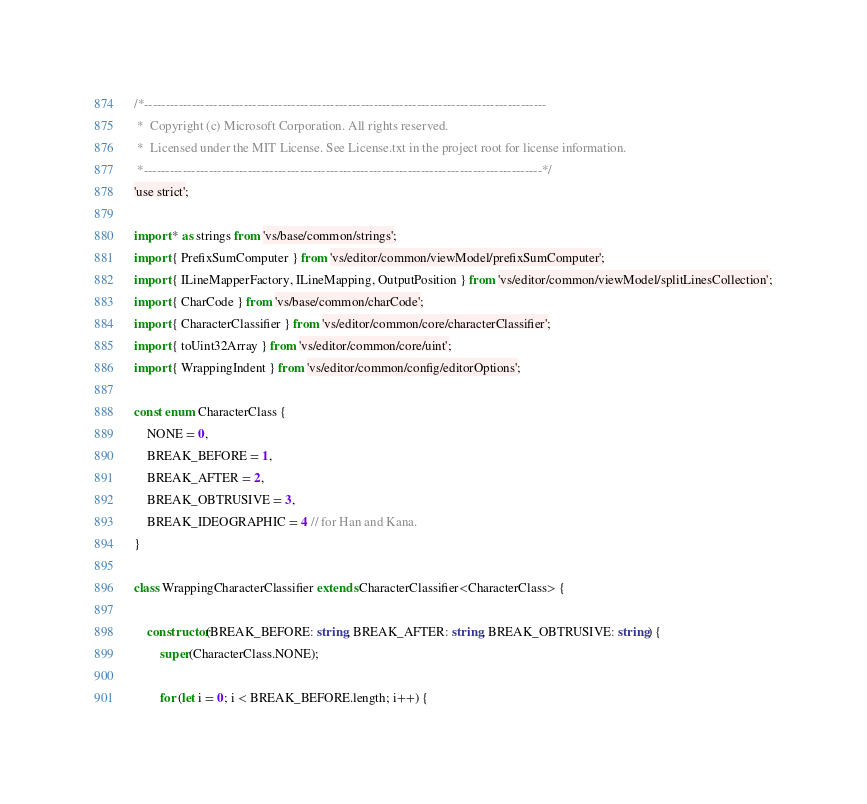Convert code to text. <code><loc_0><loc_0><loc_500><loc_500><_TypeScript_>/*---------------------------------------------------------------------------------------------
 *  Copyright (c) Microsoft Corporation. All rights reserved.
 *  Licensed under the MIT License. See License.txt in the project root for license information.
 *--------------------------------------------------------------------------------------------*/
'use strict';

import * as strings from 'vs/base/common/strings';
import { PrefixSumComputer } from 'vs/editor/common/viewModel/prefixSumComputer';
import { ILineMapperFactory, ILineMapping, OutputPosition } from 'vs/editor/common/viewModel/splitLinesCollection';
import { CharCode } from 'vs/base/common/charCode';
import { CharacterClassifier } from 'vs/editor/common/core/characterClassifier';
import { toUint32Array } from 'vs/editor/common/core/uint';
import { WrappingIndent } from 'vs/editor/common/config/editorOptions';

const enum CharacterClass {
	NONE = 0,
	BREAK_BEFORE = 1,
	BREAK_AFTER = 2,
	BREAK_OBTRUSIVE = 3,
	BREAK_IDEOGRAPHIC = 4 // for Han and Kana.
}

class WrappingCharacterClassifier extends CharacterClassifier<CharacterClass> {

	constructor(BREAK_BEFORE: string, BREAK_AFTER: string, BREAK_OBTRUSIVE: string) {
		super(CharacterClass.NONE);

		for (let i = 0; i < BREAK_BEFORE.length; i++) {</code> 